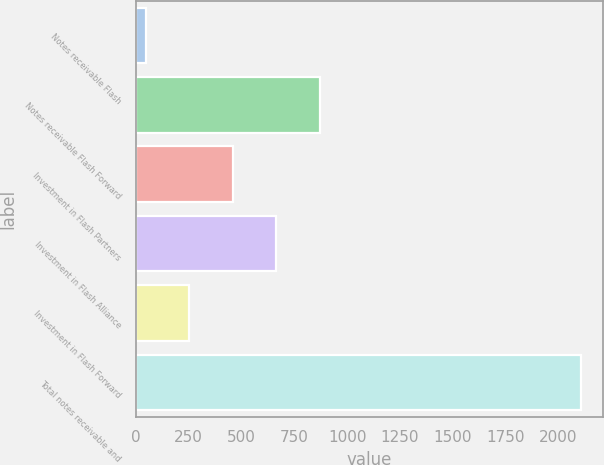Convert chart. <chart><loc_0><loc_0><loc_500><loc_500><bar_chart><fcel>Notes receivable Flash<fcel>Notes receivable Flash Forward<fcel>Investment in Flash Partners<fcel>Investment in Flash Alliance<fcel>Investment in Flash Forward<fcel>Total notes receivable and<nl><fcel>48<fcel>870.8<fcel>459.4<fcel>665.1<fcel>253.7<fcel>2105<nl></chart> 